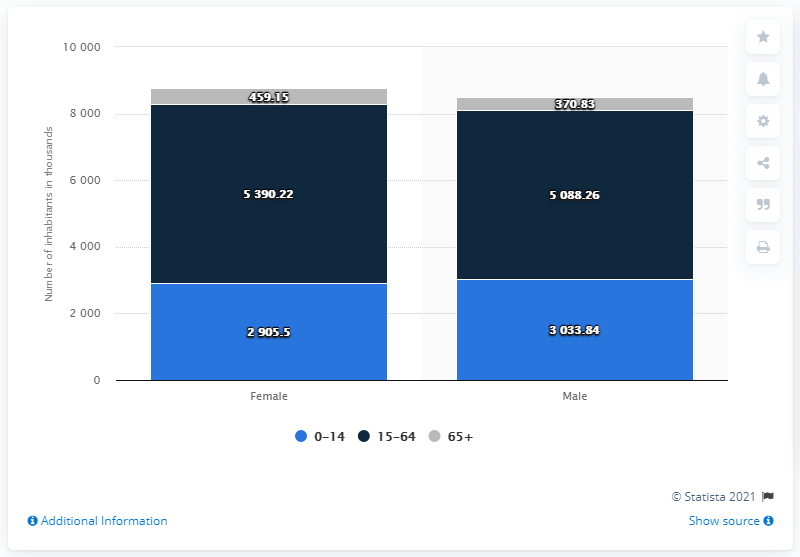Highlight a few significant elements in this photo. The average of the blue bar is 2969.67. The value of male in the 0-14 category is 3033.84. 